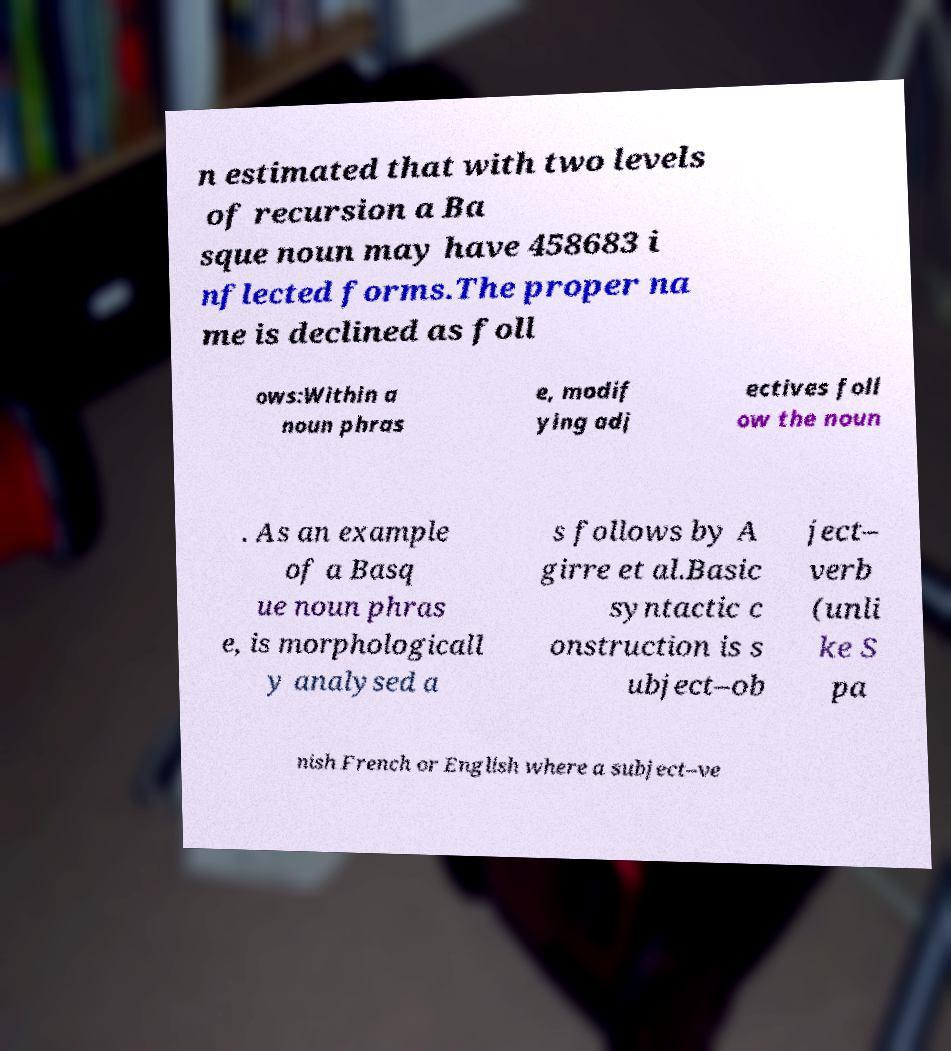Please identify and transcribe the text found in this image. n estimated that with two levels of recursion a Ba sque noun may have 458683 i nflected forms.The proper na me is declined as foll ows:Within a noun phras e, modif ying adj ectives foll ow the noun . As an example of a Basq ue noun phras e, is morphologicall y analysed a s follows by A girre et al.Basic syntactic c onstruction is s ubject–ob ject– verb (unli ke S pa nish French or English where a subject–ve 